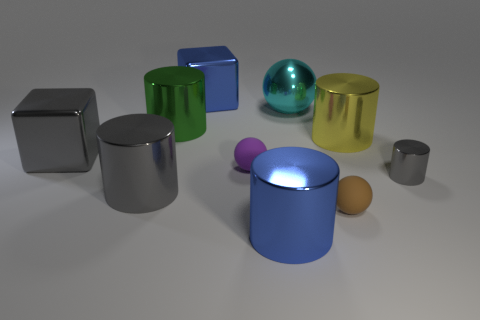What number of large objects are either rubber balls or brown matte cubes?
Keep it short and to the point. 0. What size is the green object?
Offer a very short reply. Large. Is there anything else that is made of the same material as the blue cylinder?
Offer a terse response. Yes. How many objects are on the left side of the brown thing?
Your response must be concise. 7. There is a cyan thing that is the same shape as the small brown matte object; what size is it?
Provide a succinct answer. Large. There is a cylinder that is both behind the big gray shiny block and to the right of the large cyan ball; what is its size?
Give a very brief answer. Large. Do the metal sphere and the large thing that is behind the large cyan shiny sphere have the same color?
Keep it short and to the point. No. What number of purple things are big metal cylinders or cylinders?
Your response must be concise. 0. What is the shape of the yellow object?
Offer a very short reply. Cylinder. What number of other things are there of the same shape as the purple matte object?
Offer a terse response. 2. 